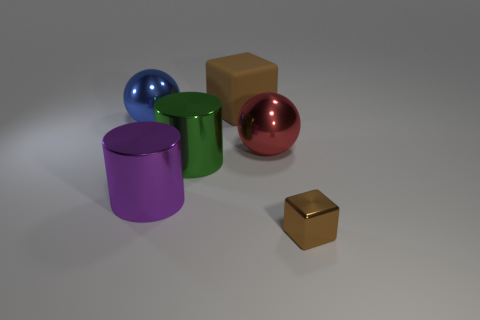Add 3 large green cylinders. How many objects exist? 9 Subtract all cubes. How many objects are left? 4 Subtract 0 gray cylinders. How many objects are left? 6 Subtract all metallic blocks. Subtract all big matte blocks. How many objects are left? 4 Add 3 tiny brown metal cubes. How many tiny brown metal cubes are left? 4 Add 1 large blue cylinders. How many large blue cylinders exist? 1 